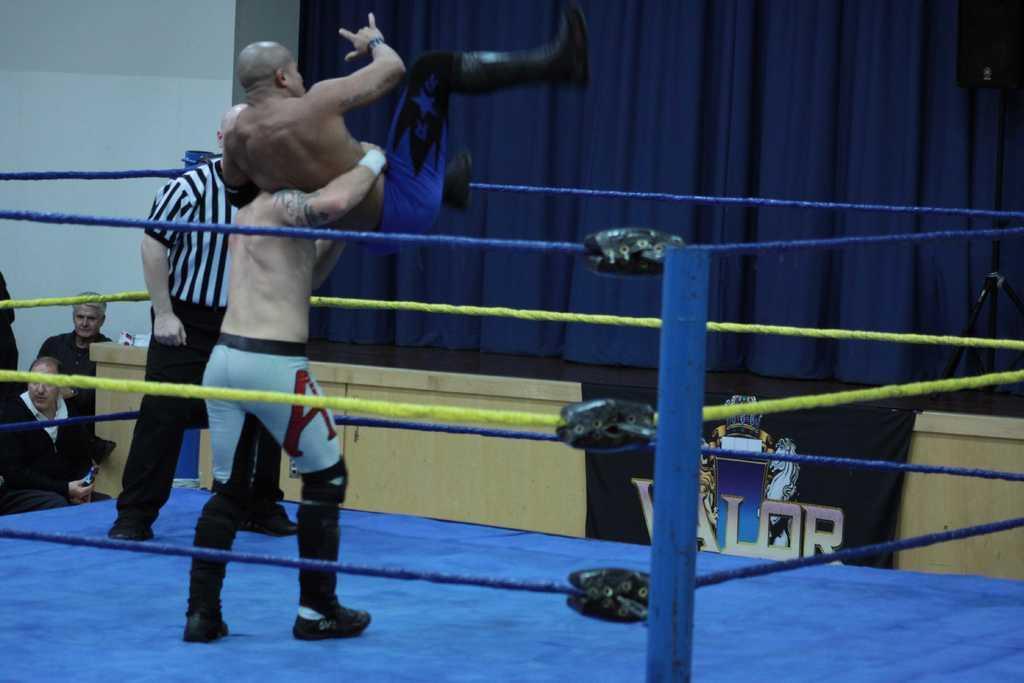Describe this image in one or two sentences. We can see a boxing court as we can see in the middle of this image. We can see people on the left side of this image. There is a curtain and a wall is in the background. We can see a stand on the right side of this image. 